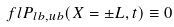<formula> <loc_0><loc_0><loc_500><loc_500>\ f l P _ { l b , u b } ( X = \pm L , t ) \equiv 0</formula> 